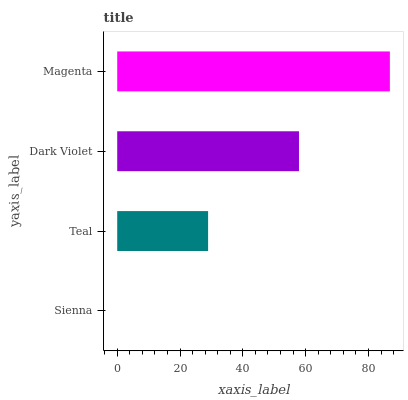Is Sienna the minimum?
Answer yes or no. Yes. Is Magenta the maximum?
Answer yes or no. Yes. Is Teal the minimum?
Answer yes or no. No. Is Teal the maximum?
Answer yes or no. No. Is Teal greater than Sienna?
Answer yes or no. Yes. Is Sienna less than Teal?
Answer yes or no. Yes. Is Sienna greater than Teal?
Answer yes or no. No. Is Teal less than Sienna?
Answer yes or no. No. Is Dark Violet the high median?
Answer yes or no. Yes. Is Teal the low median?
Answer yes or no. Yes. Is Sienna the high median?
Answer yes or no. No. Is Sienna the low median?
Answer yes or no. No. 